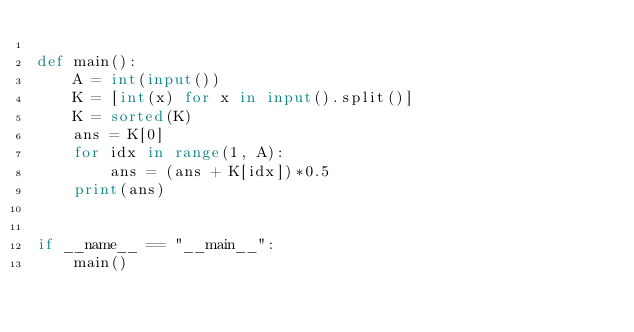Convert code to text. <code><loc_0><loc_0><loc_500><loc_500><_Python_>
def main():
    A = int(input())
    K = [int(x) for x in input().split()]
    K = sorted(K)
    ans = K[0]
    for idx in range(1, A):
        ans = (ans + K[idx])*0.5
    print(ans)


if __name__ == "__main__":
    main()
</code> 